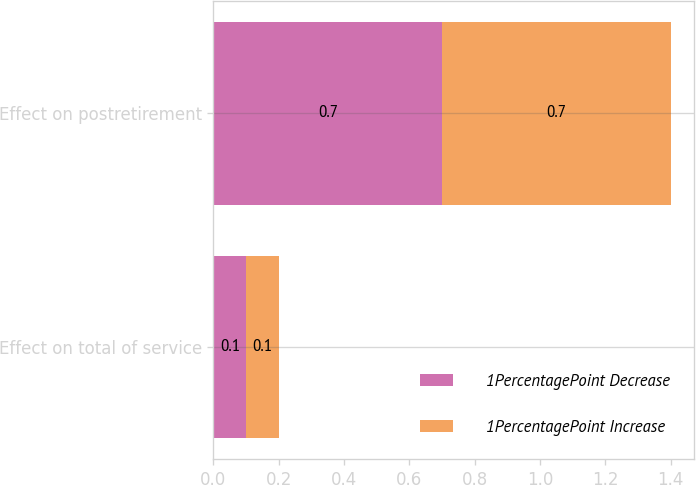Convert chart. <chart><loc_0><loc_0><loc_500><loc_500><stacked_bar_chart><ecel><fcel>Effect on total of service<fcel>Effect on postretirement<nl><fcel>1PercentagePoint Decrease<fcel>0.1<fcel>0.7<nl><fcel>1PercentagePoint Increase<fcel>0.1<fcel>0.7<nl></chart> 